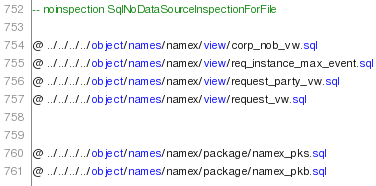Convert code to text. <code><loc_0><loc_0><loc_500><loc_500><_SQL_>-- noinspection SqlNoDataSourceInspectionForFile

@ ../../../../object/names/namex/view/corp_nob_vw.sql
@ ../../../../object/names/namex/view/req_instance_max_event.sql
@ ../../../../object/names/namex/view/request_party_vw.sql
@ ../../../../object/names/namex/view/request_vw.sql


@ ../../../../object/names/namex/package/namex_pks.sql
@ ../../../../object/names/namex/package/namex_pkb.sql</code> 